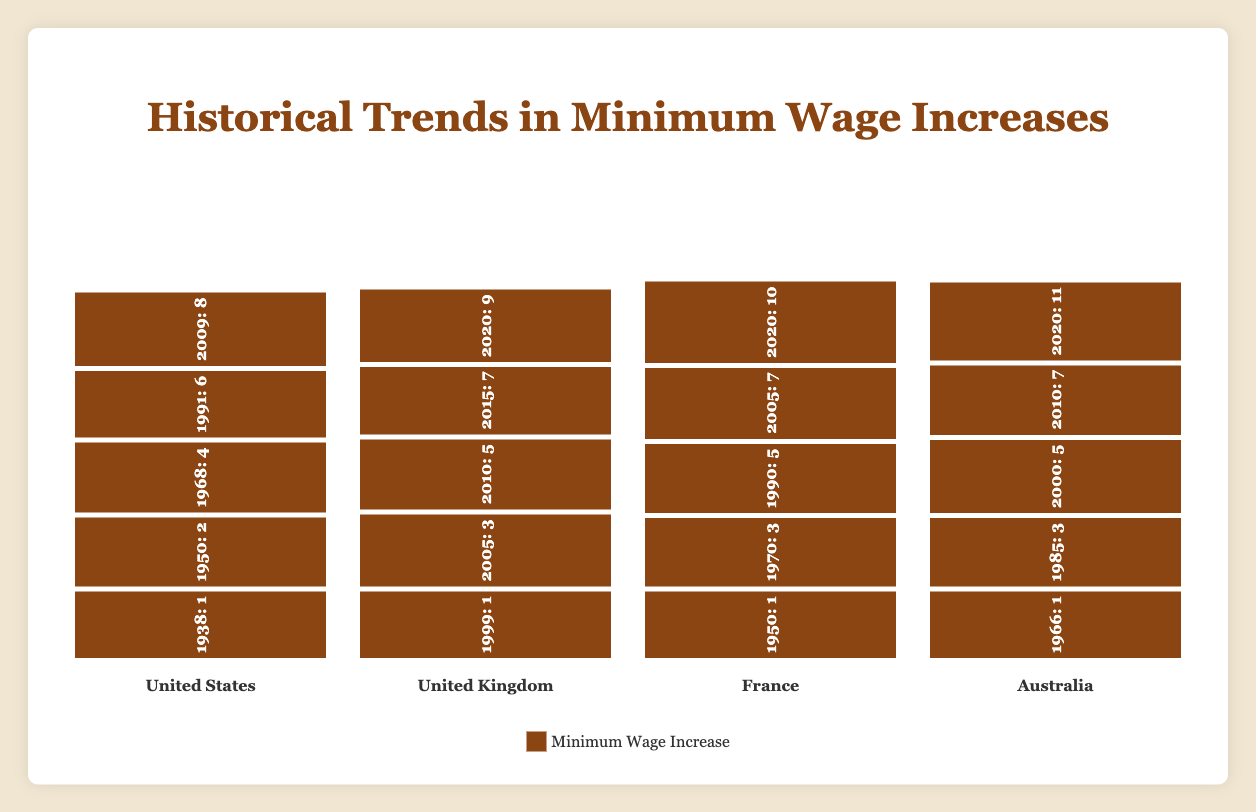What is the highest minimum wage increase for the United States in the figure? The bars for the United States show the values 1, 2, 4, 6, and 8. The tallest bar corresponds to a value of 8.
Answer: 8 Between the United Kingdom and Australia, which country had a higher minimum wage increase in 2010? The bar for the United Kingdom in 2010 shows a value of 5, whereas the bar for Australia in 2010 shows a value of 7. Australia has the higher value.
Answer: Australia What is the earliest year displayed for the minimum wage increase in France? Looking at the bars for France, the earliest year is labeled 1950.
Answer: 1950 How many minimum wage increases for the United Kingdom are recorded in the figure? The United Kingdom has wage increases recorded for the years 1999, 2005, 2010, 2015, and 2020, making a total of 5 data points.
Answer: 5 What is the total minimum wage increase for Australia across all recorded years in the figure? Summing the values for Australia: 1 + 3 + 5 + 7 + 11 = 27.
Answer: 27 Which country had the largest increase between its earliest and latest recorded years? Examine the increases: United States (8 - 1 = 7), United Kingdom (9 - 1 = 8), France (10 - 1 = 9), Australia (11 - 1 = 10). Australia has the largest increase of 10.
Answer: Australia What is the average minimum wage increase for the United States based on the figure? Sum of U.S. values: 1 + 2 + 4 + 6 + 8 = 21. Number of values: 5. Average: 21/5 = 4.2.
Answer: 4.2 How does the increase in France in 1990 compare to the United Kingdom in 2010? The bar for France in 1990 shows a value of 5. The bar for the United Kingdom in 2010 also shows a value of 5. Both are equal.
Answer: They are equal Which country experienced the smallest minimum wage increase? The smallest increase among the countries is shown by the shortest bar in each country. The United States in 1938, the United Kingdom in 1999, France in 1950, and Australia in 1966 all have an increase of 1.
Answer: All countries have an increase from 1 in their initial year In what year did France have a minimum wage increase that was exactly double that of its increase in 1950? The increase in 1950 for France was 1. An increase that is double 1 is 2. None of the bars for France show a value of 2, so this condition was never met.
Answer: Never met 